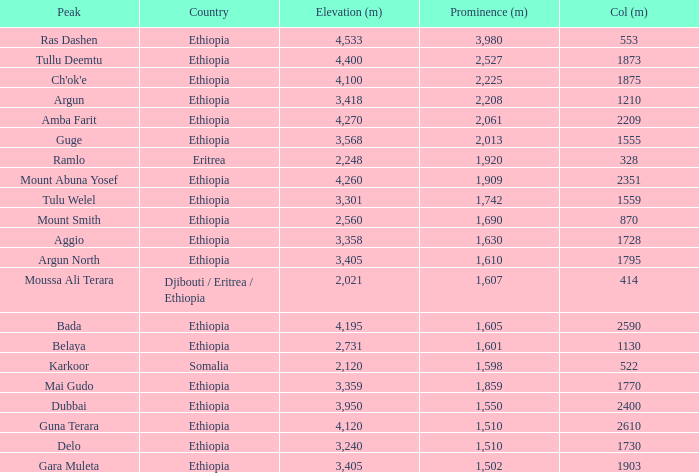What is the total prominence number in m of ethiopia, which has a col in m of 1728 and an elevation less than 3,358? 0.0. 